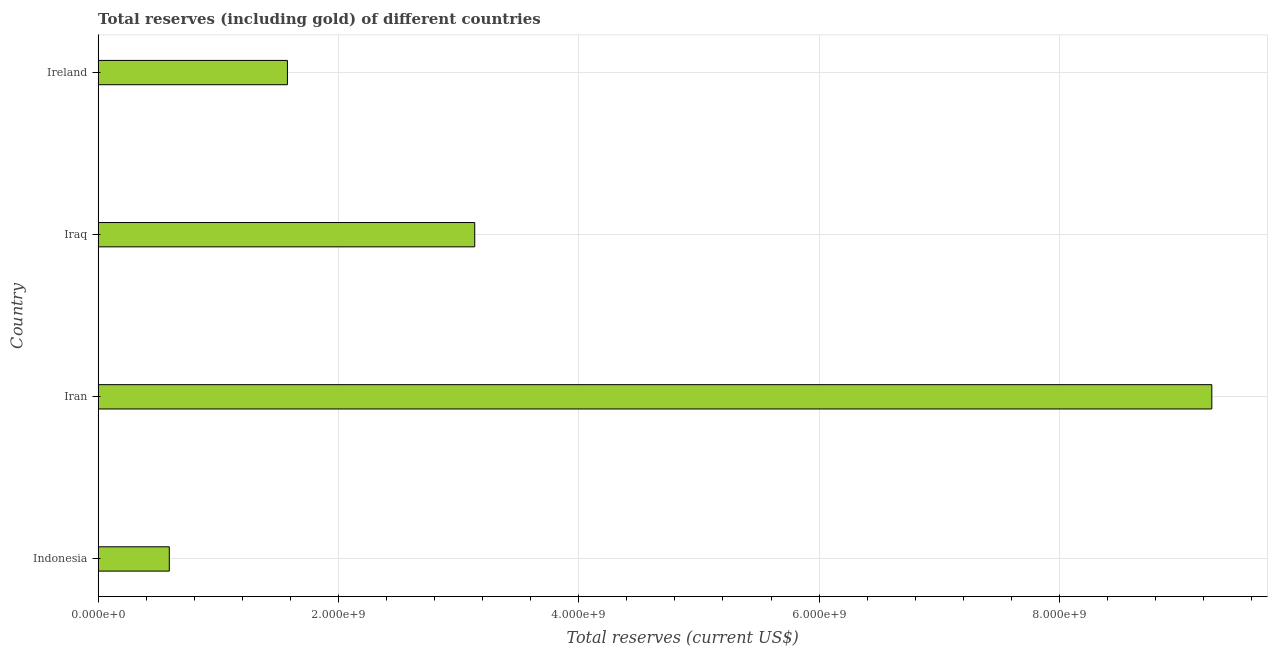Does the graph contain any zero values?
Provide a succinct answer. No. What is the title of the graph?
Offer a terse response. Total reserves (including gold) of different countries. What is the label or title of the X-axis?
Your answer should be very brief. Total reserves (current US$). What is the label or title of the Y-axis?
Give a very brief answer. Country. What is the total reserves (including gold) in Ireland?
Keep it short and to the point. 1.58e+09. Across all countries, what is the maximum total reserves (including gold)?
Keep it short and to the point. 9.27e+09. Across all countries, what is the minimum total reserves (including gold)?
Provide a succinct answer. 5.92e+08. In which country was the total reserves (including gold) maximum?
Your answer should be compact. Iran. In which country was the total reserves (including gold) minimum?
Offer a very short reply. Indonesia. What is the sum of the total reserves (including gold)?
Ensure brevity in your answer.  1.46e+1. What is the difference between the total reserves (including gold) in Indonesia and Iran?
Your answer should be very brief. -8.68e+09. What is the average total reserves (including gold) per country?
Provide a short and direct response. 3.64e+09. What is the median total reserves (including gold)?
Your answer should be compact. 2.35e+09. In how many countries, is the total reserves (including gold) greater than 800000000 US$?
Offer a terse response. 3. What is the ratio of the total reserves (including gold) in Iran to that in Ireland?
Make the answer very short. 5.88. Is the difference between the total reserves (including gold) in Indonesia and Iran greater than the difference between any two countries?
Keep it short and to the point. Yes. What is the difference between the highest and the second highest total reserves (including gold)?
Ensure brevity in your answer.  6.13e+09. What is the difference between the highest and the lowest total reserves (including gold)?
Keep it short and to the point. 8.68e+09. In how many countries, is the total reserves (including gold) greater than the average total reserves (including gold) taken over all countries?
Provide a succinct answer. 1. How many countries are there in the graph?
Ensure brevity in your answer.  4. What is the difference between two consecutive major ticks on the X-axis?
Your answer should be very brief. 2.00e+09. What is the Total reserves (current US$) in Indonesia?
Offer a terse response. 5.92e+08. What is the Total reserves (current US$) in Iran?
Keep it short and to the point. 9.27e+09. What is the Total reserves (current US$) in Iraq?
Keep it short and to the point. 3.13e+09. What is the Total reserves (current US$) in Ireland?
Give a very brief answer. 1.58e+09. What is the difference between the Total reserves (current US$) in Indonesia and Iran?
Your answer should be compact. -8.68e+09. What is the difference between the Total reserves (current US$) in Indonesia and Iraq?
Your answer should be compact. -2.54e+09. What is the difference between the Total reserves (current US$) in Indonesia and Ireland?
Provide a succinct answer. -9.83e+08. What is the difference between the Total reserves (current US$) in Iran and Iraq?
Ensure brevity in your answer.  6.13e+09. What is the difference between the Total reserves (current US$) in Iran and Ireland?
Keep it short and to the point. 7.69e+09. What is the difference between the Total reserves (current US$) in Iraq and Ireland?
Provide a succinct answer. 1.56e+09. What is the ratio of the Total reserves (current US$) in Indonesia to that in Iran?
Provide a succinct answer. 0.06. What is the ratio of the Total reserves (current US$) in Indonesia to that in Iraq?
Keep it short and to the point. 0.19. What is the ratio of the Total reserves (current US$) in Indonesia to that in Ireland?
Your answer should be compact. 0.38. What is the ratio of the Total reserves (current US$) in Iran to that in Iraq?
Provide a succinct answer. 2.96. What is the ratio of the Total reserves (current US$) in Iran to that in Ireland?
Your response must be concise. 5.88. What is the ratio of the Total reserves (current US$) in Iraq to that in Ireland?
Offer a very short reply. 1.99. 